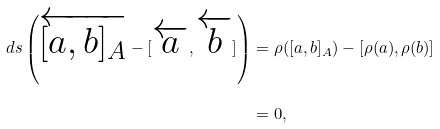<formula> <loc_0><loc_0><loc_500><loc_500>d s \left ( \overleftarrow { [ a , b ] _ { A } } - [ \overleftarrow { a } , \overleftarrow { b } ] \right ) & = \rho ( [ a , b ] _ { A } ) - [ \rho ( a ) , \rho ( b ) ] \\ & = 0 ,</formula> 